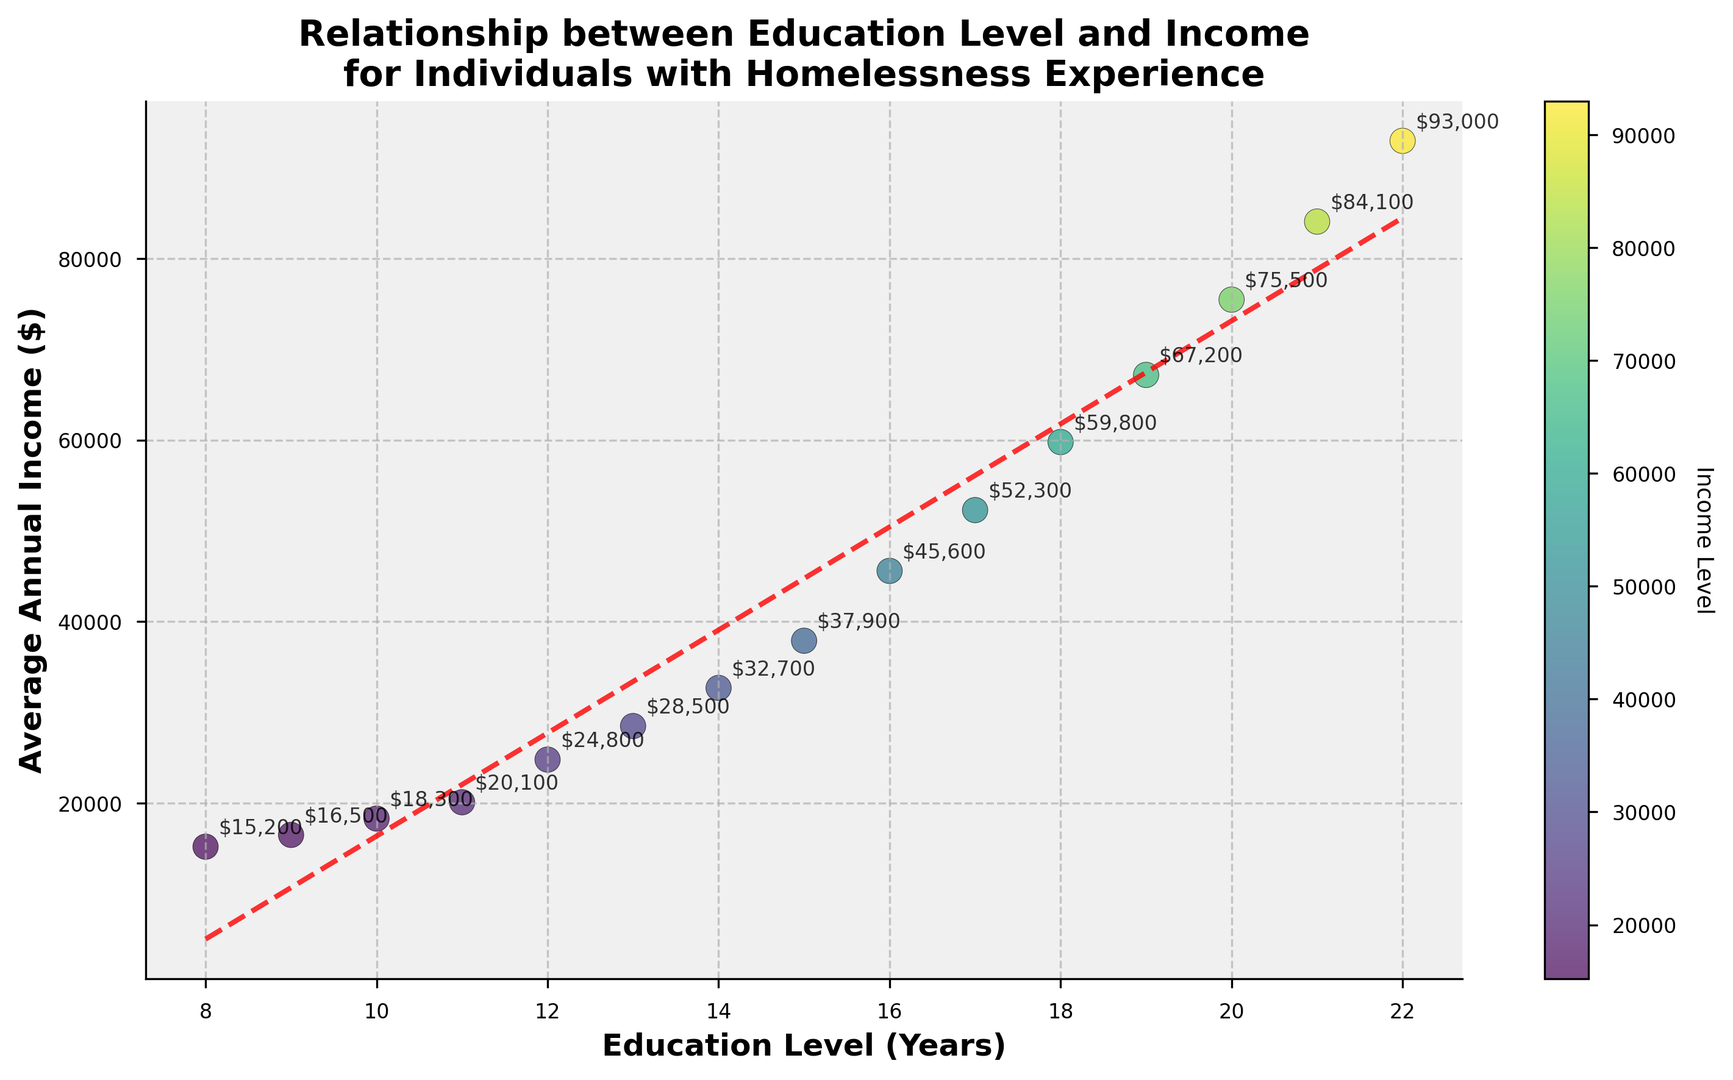Which education level has the lowest average annual income? To find the lowest average annual income, look for the smallest y-coordinate on the scatter plot. It corresponds to the data point where the average annual income is $15,200, which is at 8 years of education.
Answer: 8 years How does the average annual income change from 12 years to 16 years of education? First, locate the data points for 12 years and 16 years of education. The average annual income at 12 years is $24,800, and at 16 years, it is $45,600. Subtract $24,800 from $45,600 to find the difference, which is $20,800.
Answer: Increases by $20,800 What is the average annual income for individuals with 14 years and 18 years of education combined? Find the income values for 14 years ($32,700) and 18 years ($59,800) of education. Sum these values: $32,700 + $59,800 = $92,500. Now, divide by 2 to get the average: $92,500 / 2 = $46,250.
Answer: $46,250 Which education level shows a sudden jump in average annual income compared to the previous level? Check the values of average annual income between consecutive education levels. Identify where the difference is notably larger. Between 15 years ($37,900) and 16 years ($45,600) of education, the difference is $7,700, which is a significant jump compared to other intervals.
Answer: From 15 to 16 years What average annual income corresponds to the highest education level on the plot? Identify the highest education level on the x-axis, which is 22 years, and look up the corresponding y-coordinate, which is $93,000.
Answer: $93,000 How much does the average annual income increase from 8 years to 12 years of education? Check the income values for 8 years ($15,200) and 12 years ($24,800). Subtract $15,200 from $24,800: $24,800 - $15,200 = $9,600.
Answer: Increases by $9,600 What is the visual trend indicated by the line on the scatter plot? Observe the red dashed line fitted through the scatter points. This line generally slopes upwards, indicating a positive correlation where higher education levels are associated with higher average annual incomes.
Answer: Positive correlation What color is the scatter plot data point with the second-highest average annual income and what does this indicate about its income level? Identify the data point with the second-highest average annual income, which corresponds to 21 years of education ($84,100). The color of this point is a shade of green, darker than most others, indicating a high-income level.
Answer: Dark green, high income Which has a higher average annual income: individuals with 13 years of education or individuals with 17 years of education? Find the income values for 13 years ($28,500) and 17 years ($52,300) of education. Since $52,300 is greater than $28,500, individuals with 17 years of education have a higher average annual income.
Answer: 17 years What is the text annotation for the data point with the lowest education level? Locate the point with the lowest education level (8 years). According to the annotation, the average annual income is labeled as $15,200.
Answer: $15,200 